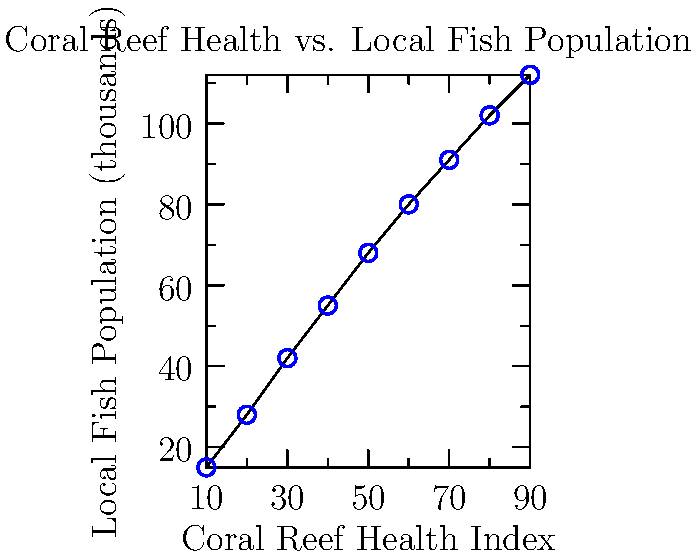Based on the scatter plot showing the relationship between coral reef health and local fish populations, what policy recommendation would you make to ensure sustainable fisheries and protect coral reef ecosystems? To answer this question, let's analyze the scatter plot step-by-step:

1. Observe the overall trend: There is a clear positive correlation between coral reef health and local fish populations.

2. Interpret the correlation: As the coral reef health index increases, the local fish population also increases.

3. Understand the implications:
   a. Healthy coral reefs support larger fish populations.
   b. Degradation of coral reefs likely leads to decreased fish populations.

4. Consider the economic impact:
   a. Larger fish populations support local fishing industries.
   b. Healthy coral reefs contribute to tourism revenue.

5. Recognize the ecological importance:
   a. Coral reefs are biodiversity hotspots.
   b. They play a crucial role in marine ecosystems.

6. Formulate a policy recommendation:
   a. Implement measures to protect and improve coral reef health.
   b. Establish sustainable fishing practices to maintain fish populations.
   c. Create marine protected areas to allow reef recovery and fish stock replenishment.
   d. Invest in research and monitoring of coral reef ecosystems.

7. Consider long-term benefits:
   a. Sustainable fisheries ensure long-term economic stability for coastal communities.
   b. Healthy coral reefs provide ecosystem services such as coastal protection and carbon sequestration.

Given these considerations, a comprehensive policy approach that prioritizes coral reef conservation while supporting sustainable fishing practices would be most effective.
Answer: Implement coral reef protection measures and sustainable fishing practices to ensure long-term economic and ecological benefits. 